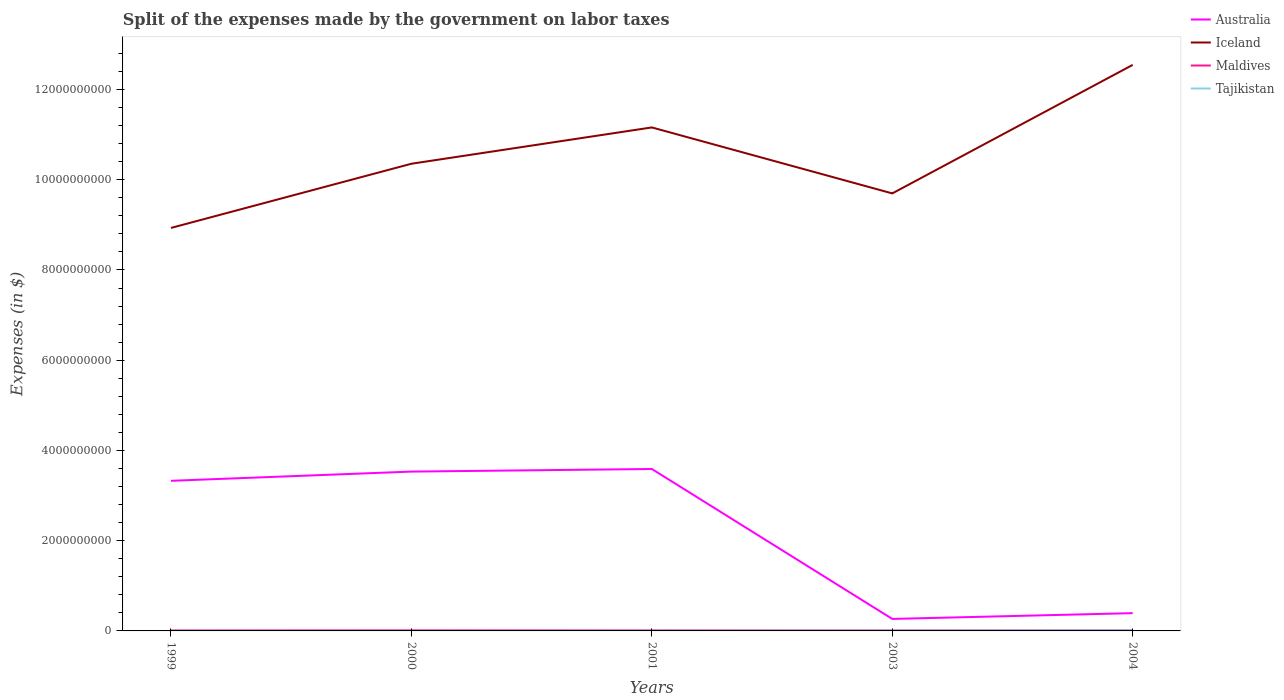How many different coloured lines are there?
Give a very brief answer. 4. Is the number of lines equal to the number of legend labels?
Your response must be concise. Yes. Across all years, what is the maximum expenses made by the government on labor taxes in Maldives?
Provide a succinct answer. 1.06e+07. What is the total expenses made by the government on labor taxes in Australia in the graph?
Provide a short and direct response. 3.26e+09. What is the difference between the highest and the second highest expenses made by the government on labor taxes in Iceland?
Your answer should be compact. 3.61e+09. Is the expenses made by the government on labor taxes in Iceland strictly greater than the expenses made by the government on labor taxes in Tajikistan over the years?
Provide a short and direct response. No. How many years are there in the graph?
Your answer should be very brief. 5. What is the difference between two consecutive major ticks on the Y-axis?
Your answer should be very brief. 2.00e+09. Does the graph contain any zero values?
Offer a very short reply. No. Does the graph contain grids?
Ensure brevity in your answer.  No. Where does the legend appear in the graph?
Your answer should be very brief. Top right. What is the title of the graph?
Your answer should be compact. Split of the expenses made by the government on labor taxes. What is the label or title of the X-axis?
Offer a very short reply. Years. What is the label or title of the Y-axis?
Your response must be concise. Expenses (in $). What is the Expenses (in $) of Australia in 1999?
Your answer should be very brief. 3.33e+09. What is the Expenses (in $) of Iceland in 1999?
Ensure brevity in your answer.  8.93e+09. What is the Expenses (in $) of Maldives in 1999?
Offer a terse response. 1.11e+07. What is the Expenses (in $) in Tajikistan in 1999?
Give a very brief answer. 2.09e+06. What is the Expenses (in $) of Australia in 2000?
Your response must be concise. 3.53e+09. What is the Expenses (in $) in Iceland in 2000?
Ensure brevity in your answer.  1.04e+1. What is the Expenses (in $) of Maldives in 2000?
Offer a terse response. 1.34e+07. What is the Expenses (in $) in Tajikistan in 2000?
Ensure brevity in your answer.  1.83e+06. What is the Expenses (in $) of Australia in 2001?
Your answer should be very brief. 3.59e+09. What is the Expenses (in $) in Iceland in 2001?
Your response must be concise. 1.12e+1. What is the Expenses (in $) in Maldives in 2001?
Provide a short and direct response. 1.19e+07. What is the Expenses (in $) of Tajikistan in 2001?
Keep it short and to the point. 3.17e+06. What is the Expenses (in $) in Australia in 2003?
Offer a terse response. 2.66e+08. What is the Expenses (in $) of Iceland in 2003?
Provide a succinct answer. 9.70e+09. What is the Expenses (in $) in Maldives in 2003?
Keep it short and to the point. 1.06e+07. What is the Expenses (in $) in Tajikistan in 2003?
Offer a terse response. 7.63e+06. What is the Expenses (in $) in Australia in 2004?
Give a very brief answer. 3.94e+08. What is the Expenses (in $) in Iceland in 2004?
Give a very brief answer. 1.25e+1. What is the Expenses (in $) of Maldives in 2004?
Make the answer very short. 1.22e+07. What is the Expenses (in $) in Tajikistan in 2004?
Ensure brevity in your answer.  1.14e+07. Across all years, what is the maximum Expenses (in $) of Australia?
Make the answer very short. 3.59e+09. Across all years, what is the maximum Expenses (in $) in Iceland?
Give a very brief answer. 1.25e+1. Across all years, what is the maximum Expenses (in $) in Maldives?
Offer a terse response. 1.34e+07. Across all years, what is the maximum Expenses (in $) in Tajikistan?
Make the answer very short. 1.14e+07. Across all years, what is the minimum Expenses (in $) in Australia?
Provide a short and direct response. 2.66e+08. Across all years, what is the minimum Expenses (in $) in Iceland?
Provide a short and direct response. 8.93e+09. Across all years, what is the minimum Expenses (in $) in Maldives?
Your response must be concise. 1.06e+07. Across all years, what is the minimum Expenses (in $) of Tajikistan?
Your answer should be very brief. 1.83e+06. What is the total Expenses (in $) in Australia in the graph?
Ensure brevity in your answer.  1.11e+1. What is the total Expenses (in $) in Iceland in the graph?
Offer a terse response. 5.27e+1. What is the total Expenses (in $) of Maldives in the graph?
Keep it short and to the point. 5.92e+07. What is the total Expenses (in $) of Tajikistan in the graph?
Provide a short and direct response. 2.61e+07. What is the difference between the Expenses (in $) of Australia in 1999 and that in 2000?
Provide a succinct answer. -2.04e+08. What is the difference between the Expenses (in $) of Iceland in 1999 and that in 2000?
Your answer should be very brief. -1.42e+09. What is the difference between the Expenses (in $) in Maldives in 1999 and that in 2000?
Keep it short and to the point. -2.30e+06. What is the difference between the Expenses (in $) in Tajikistan in 1999 and that in 2000?
Your answer should be compact. 2.58e+05. What is the difference between the Expenses (in $) of Australia in 1999 and that in 2001?
Ensure brevity in your answer.  -2.62e+08. What is the difference between the Expenses (in $) of Iceland in 1999 and that in 2001?
Your response must be concise. -2.23e+09. What is the difference between the Expenses (in $) of Maldives in 1999 and that in 2001?
Provide a succinct answer. -8.00e+05. What is the difference between the Expenses (in $) of Tajikistan in 1999 and that in 2001?
Provide a succinct answer. -1.08e+06. What is the difference between the Expenses (in $) in Australia in 1999 and that in 2003?
Provide a short and direct response. 3.06e+09. What is the difference between the Expenses (in $) in Iceland in 1999 and that in 2003?
Your answer should be compact. -7.65e+08. What is the difference between the Expenses (in $) in Tajikistan in 1999 and that in 2003?
Offer a terse response. -5.54e+06. What is the difference between the Expenses (in $) in Australia in 1999 and that in 2004?
Ensure brevity in your answer.  2.93e+09. What is the difference between the Expenses (in $) of Iceland in 1999 and that in 2004?
Keep it short and to the point. -3.61e+09. What is the difference between the Expenses (in $) in Maldives in 1999 and that in 2004?
Ensure brevity in your answer.  -1.10e+06. What is the difference between the Expenses (in $) in Tajikistan in 1999 and that in 2004?
Provide a succinct answer. -9.27e+06. What is the difference between the Expenses (in $) in Australia in 2000 and that in 2001?
Your response must be concise. -5.80e+07. What is the difference between the Expenses (in $) of Iceland in 2000 and that in 2001?
Offer a terse response. -8.05e+08. What is the difference between the Expenses (in $) of Maldives in 2000 and that in 2001?
Your response must be concise. 1.50e+06. What is the difference between the Expenses (in $) of Tajikistan in 2000 and that in 2001?
Ensure brevity in your answer.  -1.34e+06. What is the difference between the Expenses (in $) of Australia in 2000 and that in 2003?
Offer a terse response. 3.26e+09. What is the difference between the Expenses (in $) in Iceland in 2000 and that in 2003?
Offer a terse response. 6.57e+08. What is the difference between the Expenses (in $) of Maldives in 2000 and that in 2003?
Make the answer very short. 2.80e+06. What is the difference between the Expenses (in $) of Tajikistan in 2000 and that in 2003?
Offer a terse response. -5.80e+06. What is the difference between the Expenses (in $) in Australia in 2000 and that in 2004?
Your answer should be very brief. 3.14e+09. What is the difference between the Expenses (in $) in Iceland in 2000 and that in 2004?
Offer a terse response. -2.19e+09. What is the difference between the Expenses (in $) in Maldives in 2000 and that in 2004?
Provide a succinct answer. 1.20e+06. What is the difference between the Expenses (in $) of Tajikistan in 2000 and that in 2004?
Your response must be concise. -9.53e+06. What is the difference between the Expenses (in $) in Australia in 2001 and that in 2003?
Your answer should be very brief. 3.32e+09. What is the difference between the Expenses (in $) in Iceland in 2001 and that in 2003?
Provide a succinct answer. 1.46e+09. What is the difference between the Expenses (in $) of Maldives in 2001 and that in 2003?
Ensure brevity in your answer.  1.30e+06. What is the difference between the Expenses (in $) in Tajikistan in 2001 and that in 2003?
Your response must be concise. -4.46e+06. What is the difference between the Expenses (in $) of Australia in 2001 and that in 2004?
Keep it short and to the point. 3.20e+09. What is the difference between the Expenses (in $) in Iceland in 2001 and that in 2004?
Your response must be concise. -1.39e+09. What is the difference between the Expenses (in $) in Maldives in 2001 and that in 2004?
Your answer should be very brief. -3.00e+05. What is the difference between the Expenses (in $) in Tajikistan in 2001 and that in 2004?
Provide a short and direct response. -8.18e+06. What is the difference between the Expenses (in $) in Australia in 2003 and that in 2004?
Your response must be concise. -1.28e+08. What is the difference between the Expenses (in $) of Iceland in 2003 and that in 2004?
Keep it short and to the point. -2.85e+09. What is the difference between the Expenses (in $) of Maldives in 2003 and that in 2004?
Provide a succinct answer. -1.60e+06. What is the difference between the Expenses (in $) in Tajikistan in 2003 and that in 2004?
Offer a very short reply. -3.73e+06. What is the difference between the Expenses (in $) of Australia in 1999 and the Expenses (in $) of Iceland in 2000?
Keep it short and to the point. -7.03e+09. What is the difference between the Expenses (in $) in Australia in 1999 and the Expenses (in $) in Maldives in 2000?
Keep it short and to the point. 3.31e+09. What is the difference between the Expenses (in $) in Australia in 1999 and the Expenses (in $) in Tajikistan in 2000?
Ensure brevity in your answer.  3.33e+09. What is the difference between the Expenses (in $) of Iceland in 1999 and the Expenses (in $) of Maldives in 2000?
Keep it short and to the point. 8.92e+09. What is the difference between the Expenses (in $) in Iceland in 1999 and the Expenses (in $) in Tajikistan in 2000?
Your answer should be very brief. 8.93e+09. What is the difference between the Expenses (in $) in Maldives in 1999 and the Expenses (in $) in Tajikistan in 2000?
Your response must be concise. 9.27e+06. What is the difference between the Expenses (in $) in Australia in 1999 and the Expenses (in $) in Iceland in 2001?
Keep it short and to the point. -7.83e+09. What is the difference between the Expenses (in $) of Australia in 1999 and the Expenses (in $) of Maldives in 2001?
Offer a terse response. 3.32e+09. What is the difference between the Expenses (in $) in Australia in 1999 and the Expenses (in $) in Tajikistan in 2001?
Your response must be concise. 3.32e+09. What is the difference between the Expenses (in $) of Iceland in 1999 and the Expenses (in $) of Maldives in 2001?
Offer a terse response. 8.92e+09. What is the difference between the Expenses (in $) in Iceland in 1999 and the Expenses (in $) in Tajikistan in 2001?
Ensure brevity in your answer.  8.93e+09. What is the difference between the Expenses (in $) in Maldives in 1999 and the Expenses (in $) in Tajikistan in 2001?
Your answer should be compact. 7.93e+06. What is the difference between the Expenses (in $) in Australia in 1999 and the Expenses (in $) in Iceland in 2003?
Your answer should be very brief. -6.37e+09. What is the difference between the Expenses (in $) in Australia in 1999 and the Expenses (in $) in Maldives in 2003?
Your response must be concise. 3.32e+09. What is the difference between the Expenses (in $) of Australia in 1999 and the Expenses (in $) of Tajikistan in 2003?
Ensure brevity in your answer.  3.32e+09. What is the difference between the Expenses (in $) of Iceland in 1999 and the Expenses (in $) of Maldives in 2003?
Keep it short and to the point. 8.92e+09. What is the difference between the Expenses (in $) of Iceland in 1999 and the Expenses (in $) of Tajikistan in 2003?
Provide a succinct answer. 8.92e+09. What is the difference between the Expenses (in $) of Maldives in 1999 and the Expenses (in $) of Tajikistan in 2003?
Offer a terse response. 3.47e+06. What is the difference between the Expenses (in $) in Australia in 1999 and the Expenses (in $) in Iceland in 2004?
Ensure brevity in your answer.  -9.22e+09. What is the difference between the Expenses (in $) in Australia in 1999 and the Expenses (in $) in Maldives in 2004?
Give a very brief answer. 3.31e+09. What is the difference between the Expenses (in $) of Australia in 1999 and the Expenses (in $) of Tajikistan in 2004?
Give a very brief answer. 3.32e+09. What is the difference between the Expenses (in $) in Iceland in 1999 and the Expenses (in $) in Maldives in 2004?
Provide a succinct answer. 8.92e+09. What is the difference between the Expenses (in $) in Iceland in 1999 and the Expenses (in $) in Tajikistan in 2004?
Give a very brief answer. 8.92e+09. What is the difference between the Expenses (in $) of Maldives in 1999 and the Expenses (in $) of Tajikistan in 2004?
Offer a terse response. -2.55e+05. What is the difference between the Expenses (in $) in Australia in 2000 and the Expenses (in $) in Iceland in 2001?
Give a very brief answer. -7.63e+09. What is the difference between the Expenses (in $) in Australia in 2000 and the Expenses (in $) in Maldives in 2001?
Your answer should be very brief. 3.52e+09. What is the difference between the Expenses (in $) of Australia in 2000 and the Expenses (in $) of Tajikistan in 2001?
Offer a very short reply. 3.53e+09. What is the difference between the Expenses (in $) of Iceland in 2000 and the Expenses (in $) of Maldives in 2001?
Your answer should be compact. 1.03e+1. What is the difference between the Expenses (in $) in Iceland in 2000 and the Expenses (in $) in Tajikistan in 2001?
Your answer should be compact. 1.04e+1. What is the difference between the Expenses (in $) in Maldives in 2000 and the Expenses (in $) in Tajikistan in 2001?
Make the answer very short. 1.02e+07. What is the difference between the Expenses (in $) in Australia in 2000 and the Expenses (in $) in Iceland in 2003?
Give a very brief answer. -6.17e+09. What is the difference between the Expenses (in $) in Australia in 2000 and the Expenses (in $) in Maldives in 2003?
Provide a short and direct response. 3.52e+09. What is the difference between the Expenses (in $) of Australia in 2000 and the Expenses (in $) of Tajikistan in 2003?
Offer a terse response. 3.52e+09. What is the difference between the Expenses (in $) in Iceland in 2000 and the Expenses (in $) in Maldives in 2003?
Make the answer very short. 1.03e+1. What is the difference between the Expenses (in $) in Iceland in 2000 and the Expenses (in $) in Tajikistan in 2003?
Your answer should be very brief. 1.03e+1. What is the difference between the Expenses (in $) in Maldives in 2000 and the Expenses (in $) in Tajikistan in 2003?
Offer a terse response. 5.77e+06. What is the difference between the Expenses (in $) of Australia in 2000 and the Expenses (in $) of Iceland in 2004?
Your response must be concise. -9.01e+09. What is the difference between the Expenses (in $) in Australia in 2000 and the Expenses (in $) in Maldives in 2004?
Make the answer very short. 3.52e+09. What is the difference between the Expenses (in $) in Australia in 2000 and the Expenses (in $) in Tajikistan in 2004?
Make the answer very short. 3.52e+09. What is the difference between the Expenses (in $) in Iceland in 2000 and the Expenses (in $) in Maldives in 2004?
Provide a succinct answer. 1.03e+1. What is the difference between the Expenses (in $) of Iceland in 2000 and the Expenses (in $) of Tajikistan in 2004?
Give a very brief answer. 1.03e+1. What is the difference between the Expenses (in $) of Maldives in 2000 and the Expenses (in $) of Tajikistan in 2004?
Your response must be concise. 2.04e+06. What is the difference between the Expenses (in $) in Australia in 2001 and the Expenses (in $) in Iceland in 2003?
Your response must be concise. -6.11e+09. What is the difference between the Expenses (in $) in Australia in 2001 and the Expenses (in $) in Maldives in 2003?
Ensure brevity in your answer.  3.58e+09. What is the difference between the Expenses (in $) in Australia in 2001 and the Expenses (in $) in Tajikistan in 2003?
Your response must be concise. 3.58e+09. What is the difference between the Expenses (in $) in Iceland in 2001 and the Expenses (in $) in Maldives in 2003?
Offer a very short reply. 1.11e+1. What is the difference between the Expenses (in $) in Iceland in 2001 and the Expenses (in $) in Tajikistan in 2003?
Make the answer very short. 1.12e+1. What is the difference between the Expenses (in $) in Maldives in 2001 and the Expenses (in $) in Tajikistan in 2003?
Ensure brevity in your answer.  4.27e+06. What is the difference between the Expenses (in $) in Australia in 2001 and the Expenses (in $) in Iceland in 2004?
Provide a succinct answer. -8.96e+09. What is the difference between the Expenses (in $) in Australia in 2001 and the Expenses (in $) in Maldives in 2004?
Ensure brevity in your answer.  3.58e+09. What is the difference between the Expenses (in $) in Australia in 2001 and the Expenses (in $) in Tajikistan in 2004?
Provide a short and direct response. 3.58e+09. What is the difference between the Expenses (in $) in Iceland in 2001 and the Expenses (in $) in Maldives in 2004?
Provide a succinct answer. 1.11e+1. What is the difference between the Expenses (in $) in Iceland in 2001 and the Expenses (in $) in Tajikistan in 2004?
Ensure brevity in your answer.  1.11e+1. What is the difference between the Expenses (in $) of Maldives in 2001 and the Expenses (in $) of Tajikistan in 2004?
Provide a succinct answer. 5.45e+05. What is the difference between the Expenses (in $) of Australia in 2003 and the Expenses (in $) of Iceland in 2004?
Ensure brevity in your answer.  -1.23e+1. What is the difference between the Expenses (in $) of Australia in 2003 and the Expenses (in $) of Maldives in 2004?
Make the answer very short. 2.54e+08. What is the difference between the Expenses (in $) of Australia in 2003 and the Expenses (in $) of Tajikistan in 2004?
Offer a very short reply. 2.55e+08. What is the difference between the Expenses (in $) in Iceland in 2003 and the Expenses (in $) in Maldives in 2004?
Offer a very short reply. 9.68e+09. What is the difference between the Expenses (in $) in Iceland in 2003 and the Expenses (in $) in Tajikistan in 2004?
Provide a succinct answer. 9.69e+09. What is the difference between the Expenses (in $) of Maldives in 2003 and the Expenses (in $) of Tajikistan in 2004?
Offer a very short reply. -7.55e+05. What is the average Expenses (in $) of Australia per year?
Your answer should be compact. 2.22e+09. What is the average Expenses (in $) of Iceland per year?
Provide a succinct answer. 1.05e+1. What is the average Expenses (in $) in Maldives per year?
Offer a very short reply. 1.18e+07. What is the average Expenses (in $) in Tajikistan per year?
Keep it short and to the point. 5.21e+06. In the year 1999, what is the difference between the Expenses (in $) of Australia and Expenses (in $) of Iceland?
Keep it short and to the point. -5.60e+09. In the year 1999, what is the difference between the Expenses (in $) of Australia and Expenses (in $) of Maldives?
Your response must be concise. 3.32e+09. In the year 1999, what is the difference between the Expenses (in $) in Australia and Expenses (in $) in Tajikistan?
Ensure brevity in your answer.  3.32e+09. In the year 1999, what is the difference between the Expenses (in $) of Iceland and Expenses (in $) of Maldives?
Provide a succinct answer. 8.92e+09. In the year 1999, what is the difference between the Expenses (in $) of Iceland and Expenses (in $) of Tajikistan?
Give a very brief answer. 8.93e+09. In the year 1999, what is the difference between the Expenses (in $) of Maldives and Expenses (in $) of Tajikistan?
Provide a succinct answer. 9.01e+06. In the year 2000, what is the difference between the Expenses (in $) of Australia and Expenses (in $) of Iceland?
Provide a succinct answer. -6.82e+09. In the year 2000, what is the difference between the Expenses (in $) in Australia and Expenses (in $) in Maldives?
Keep it short and to the point. 3.52e+09. In the year 2000, what is the difference between the Expenses (in $) in Australia and Expenses (in $) in Tajikistan?
Your answer should be very brief. 3.53e+09. In the year 2000, what is the difference between the Expenses (in $) in Iceland and Expenses (in $) in Maldives?
Provide a succinct answer. 1.03e+1. In the year 2000, what is the difference between the Expenses (in $) in Iceland and Expenses (in $) in Tajikistan?
Ensure brevity in your answer.  1.04e+1. In the year 2000, what is the difference between the Expenses (in $) in Maldives and Expenses (in $) in Tajikistan?
Offer a very short reply. 1.16e+07. In the year 2001, what is the difference between the Expenses (in $) in Australia and Expenses (in $) in Iceland?
Offer a very short reply. -7.57e+09. In the year 2001, what is the difference between the Expenses (in $) in Australia and Expenses (in $) in Maldives?
Offer a terse response. 3.58e+09. In the year 2001, what is the difference between the Expenses (in $) in Australia and Expenses (in $) in Tajikistan?
Make the answer very short. 3.59e+09. In the year 2001, what is the difference between the Expenses (in $) of Iceland and Expenses (in $) of Maldives?
Ensure brevity in your answer.  1.11e+1. In the year 2001, what is the difference between the Expenses (in $) of Iceland and Expenses (in $) of Tajikistan?
Keep it short and to the point. 1.12e+1. In the year 2001, what is the difference between the Expenses (in $) in Maldives and Expenses (in $) in Tajikistan?
Offer a terse response. 8.73e+06. In the year 2003, what is the difference between the Expenses (in $) in Australia and Expenses (in $) in Iceland?
Keep it short and to the point. -9.43e+09. In the year 2003, what is the difference between the Expenses (in $) of Australia and Expenses (in $) of Maldives?
Your answer should be very brief. 2.55e+08. In the year 2003, what is the difference between the Expenses (in $) of Australia and Expenses (in $) of Tajikistan?
Provide a succinct answer. 2.58e+08. In the year 2003, what is the difference between the Expenses (in $) in Iceland and Expenses (in $) in Maldives?
Your answer should be compact. 9.69e+09. In the year 2003, what is the difference between the Expenses (in $) in Iceland and Expenses (in $) in Tajikistan?
Provide a succinct answer. 9.69e+09. In the year 2003, what is the difference between the Expenses (in $) in Maldives and Expenses (in $) in Tajikistan?
Give a very brief answer. 2.97e+06. In the year 2004, what is the difference between the Expenses (in $) of Australia and Expenses (in $) of Iceland?
Offer a terse response. -1.22e+1. In the year 2004, what is the difference between the Expenses (in $) in Australia and Expenses (in $) in Maldives?
Give a very brief answer. 3.82e+08. In the year 2004, what is the difference between the Expenses (in $) of Australia and Expenses (in $) of Tajikistan?
Provide a short and direct response. 3.83e+08. In the year 2004, what is the difference between the Expenses (in $) of Iceland and Expenses (in $) of Maldives?
Offer a terse response. 1.25e+1. In the year 2004, what is the difference between the Expenses (in $) in Iceland and Expenses (in $) in Tajikistan?
Provide a succinct answer. 1.25e+1. In the year 2004, what is the difference between the Expenses (in $) in Maldives and Expenses (in $) in Tajikistan?
Give a very brief answer. 8.45e+05. What is the ratio of the Expenses (in $) of Australia in 1999 to that in 2000?
Your answer should be compact. 0.94. What is the ratio of the Expenses (in $) of Iceland in 1999 to that in 2000?
Provide a short and direct response. 0.86. What is the ratio of the Expenses (in $) of Maldives in 1999 to that in 2000?
Your answer should be very brief. 0.83. What is the ratio of the Expenses (in $) in Tajikistan in 1999 to that in 2000?
Keep it short and to the point. 1.14. What is the ratio of the Expenses (in $) of Australia in 1999 to that in 2001?
Ensure brevity in your answer.  0.93. What is the ratio of the Expenses (in $) in Iceland in 1999 to that in 2001?
Make the answer very short. 0.8. What is the ratio of the Expenses (in $) in Maldives in 1999 to that in 2001?
Provide a short and direct response. 0.93. What is the ratio of the Expenses (in $) in Tajikistan in 1999 to that in 2001?
Provide a succinct answer. 0.66. What is the ratio of the Expenses (in $) in Australia in 1999 to that in 2003?
Offer a terse response. 12.51. What is the ratio of the Expenses (in $) of Iceland in 1999 to that in 2003?
Provide a succinct answer. 0.92. What is the ratio of the Expenses (in $) in Maldives in 1999 to that in 2003?
Give a very brief answer. 1.05. What is the ratio of the Expenses (in $) in Tajikistan in 1999 to that in 2003?
Keep it short and to the point. 0.27. What is the ratio of the Expenses (in $) in Australia in 1999 to that in 2004?
Provide a short and direct response. 8.44. What is the ratio of the Expenses (in $) of Iceland in 1999 to that in 2004?
Ensure brevity in your answer.  0.71. What is the ratio of the Expenses (in $) in Maldives in 1999 to that in 2004?
Give a very brief answer. 0.91. What is the ratio of the Expenses (in $) of Tajikistan in 1999 to that in 2004?
Keep it short and to the point. 0.18. What is the ratio of the Expenses (in $) in Australia in 2000 to that in 2001?
Your answer should be compact. 0.98. What is the ratio of the Expenses (in $) of Iceland in 2000 to that in 2001?
Your answer should be compact. 0.93. What is the ratio of the Expenses (in $) in Maldives in 2000 to that in 2001?
Your answer should be compact. 1.13. What is the ratio of the Expenses (in $) in Tajikistan in 2000 to that in 2001?
Keep it short and to the point. 0.58. What is the ratio of the Expenses (in $) of Australia in 2000 to that in 2003?
Offer a terse response. 13.27. What is the ratio of the Expenses (in $) of Iceland in 2000 to that in 2003?
Provide a short and direct response. 1.07. What is the ratio of the Expenses (in $) of Maldives in 2000 to that in 2003?
Provide a short and direct response. 1.26. What is the ratio of the Expenses (in $) of Tajikistan in 2000 to that in 2003?
Make the answer very short. 0.24. What is the ratio of the Expenses (in $) of Australia in 2000 to that in 2004?
Give a very brief answer. 8.96. What is the ratio of the Expenses (in $) in Iceland in 2000 to that in 2004?
Offer a very short reply. 0.83. What is the ratio of the Expenses (in $) in Maldives in 2000 to that in 2004?
Ensure brevity in your answer.  1.1. What is the ratio of the Expenses (in $) of Tajikistan in 2000 to that in 2004?
Provide a short and direct response. 0.16. What is the ratio of the Expenses (in $) in Australia in 2001 to that in 2003?
Provide a short and direct response. 13.49. What is the ratio of the Expenses (in $) in Iceland in 2001 to that in 2003?
Offer a terse response. 1.15. What is the ratio of the Expenses (in $) in Maldives in 2001 to that in 2003?
Provide a succinct answer. 1.12. What is the ratio of the Expenses (in $) in Tajikistan in 2001 to that in 2003?
Keep it short and to the point. 0.42. What is the ratio of the Expenses (in $) of Australia in 2001 to that in 2004?
Offer a very short reply. 9.11. What is the ratio of the Expenses (in $) of Iceland in 2001 to that in 2004?
Provide a succinct answer. 0.89. What is the ratio of the Expenses (in $) of Maldives in 2001 to that in 2004?
Provide a succinct answer. 0.98. What is the ratio of the Expenses (in $) of Tajikistan in 2001 to that in 2004?
Your response must be concise. 0.28. What is the ratio of the Expenses (in $) of Australia in 2003 to that in 2004?
Ensure brevity in your answer.  0.68. What is the ratio of the Expenses (in $) in Iceland in 2003 to that in 2004?
Your answer should be very brief. 0.77. What is the ratio of the Expenses (in $) of Maldives in 2003 to that in 2004?
Your answer should be very brief. 0.87. What is the ratio of the Expenses (in $) in Tajikistan in 2003 to that in 2004?
Your answer should be compact. 0.67. What is the difference between the highest and the second highest Expenses (in $) of Australia?
Make the answer very short. 5.80e+07. What is the difference between the highest and the second highest Expenses (in $) in Iceland?
Make the answer very short. 1.39e+09. What is the difference between the highest and the second highest Expenses (in $) of Maldives?
Offer a terse response. 1.20e+06. What is the difference between the highest and the second highest Expenses (in $) of Tajikistan?
Provide a short and direct response. 3.73e+06. What is the difference between the highest and the lowest Expenses (in $) in Australia?
Keep it short and to the point. 3.32e+09. What is the difference between the highest and the lowest Expenses (in $) in Iceland?
Keep it short and to the point. 3.61e+09. What is the difference between the highest and the lowest Expenses (in $) of Maldives?
Make the answer very short. 2.80e+06. What is the difference between the highest and the lowest Expenses (in $) of Tajikistan?
Provide a short and direct response. 9.53e+06. 